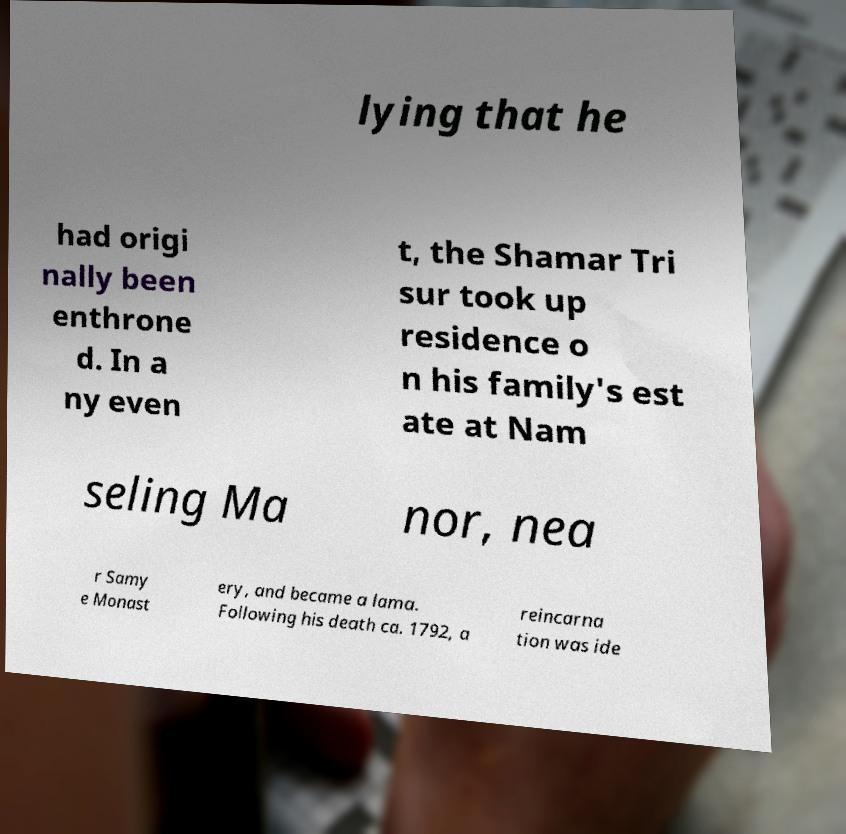There's text embedded in this image that I need extracted. Can you transcribe it verbatim? lying that he had origi nally been enthrone d. In a ny even t, the Shamar Tri sur took up residence o n his family's est ate at Nam seling Ma nor, nea r Samy e Monast ery, and became a lama. Following his death ca. 1792, a reincarna tion was ide 